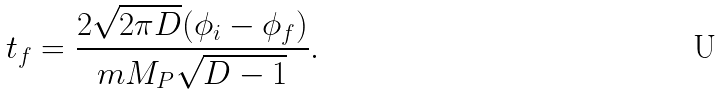Convert formula to latex. <formula><loc_0><loc_0><loc_500><loc_500>t _ { f } = \frac { 2 \sqrt { 2 \pi D } ( \phi _ { i } - \phi _ { f } ) } { m M _ { P } \sqrt { D - 1 } } .</formula> 